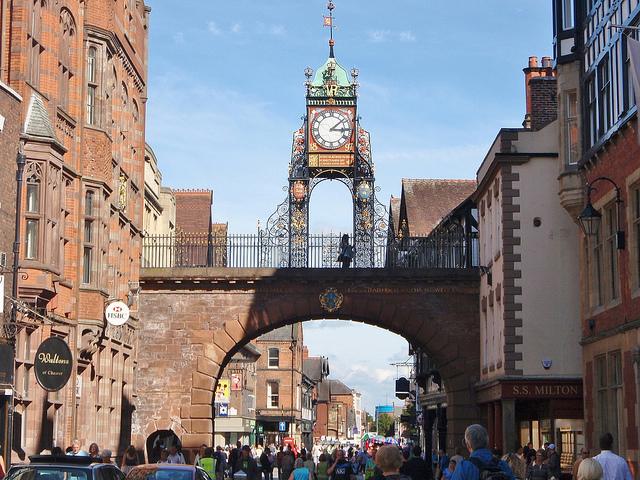What time does it say on the clock?
Keep it brief. 2:15. What time is it?
Answer briefly. 3:10. Which person is wearing a backpack?
Concise answer only. Man. What is the arch made of?
Answer briefly. Brick. To the right of backpack man, there is a sign that looks like a ship's name. What is it?
Give a very brief answer. Ss milton. Which city was this photo taken?
Give a very brief answer. Rome. 